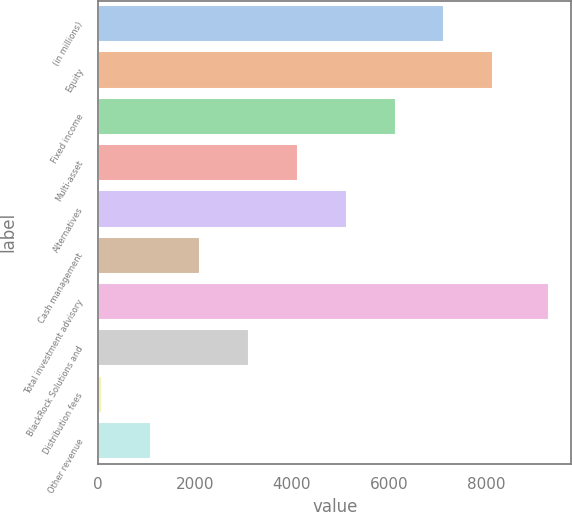<chart> <loc_0><loc_0><loc_500><loc_500><bar_chart><fcel>(in millions)<fcel>Equity<fcel>Fixed income<fcel>Multi-asset<fcel>Alternatives<fcel>Cash management<fcel>Total investment advisory<fcel>BlackRock Solutions and<fcel>Distribution fees<fcel>Other revenue<nl><fcel>7147.9<fcel>8158.6<fcel>6137.2<fcel>4115.8<fcel>5126.5<fcel>2094.4<fcel>9300<fcel>3105.1<fcel>73<fcel>1083.7<nl></chart> 